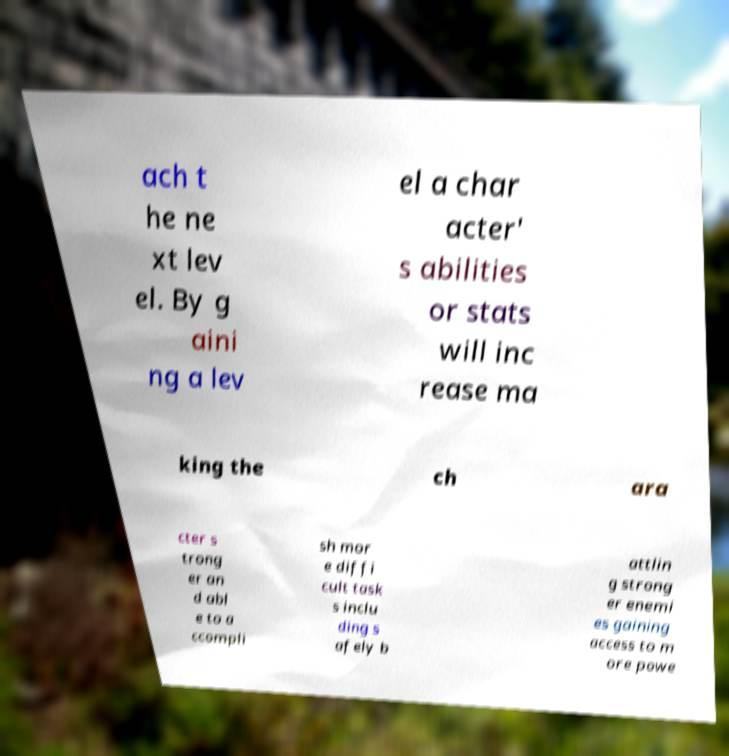Can you read and provide the text displayed in the image?This photo seems to have some interesting text. Can you extract and type it out for me? ach t he ne xt lev el. By g aini ng a lev el a char acter' s abilities or stats will inc rease ma king the ch ara cter s trong er an d abl e to a ccompli sh mor e diffi cult task s inclu ding s afely b attlin g strong er enemi es gaining access to m ore powe 